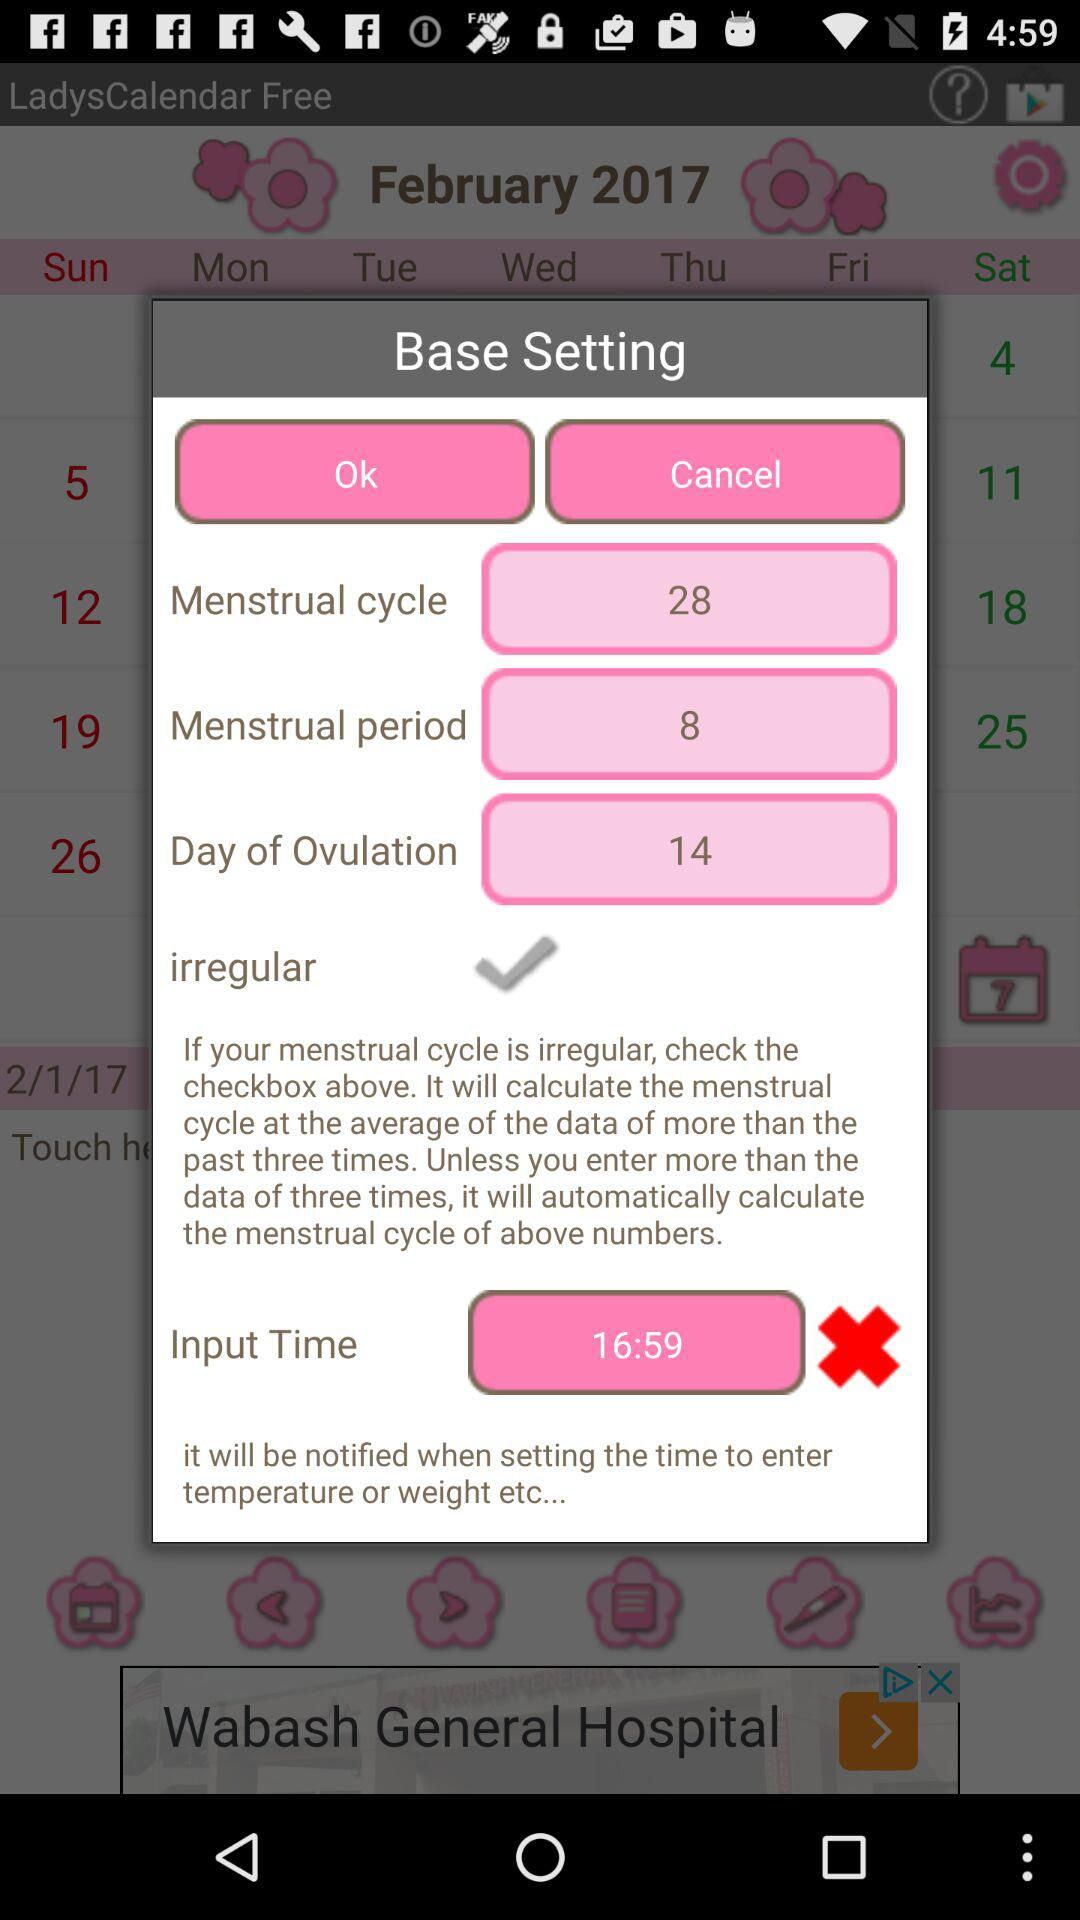What is the menstrual period? The menstrual period is 8 days. 